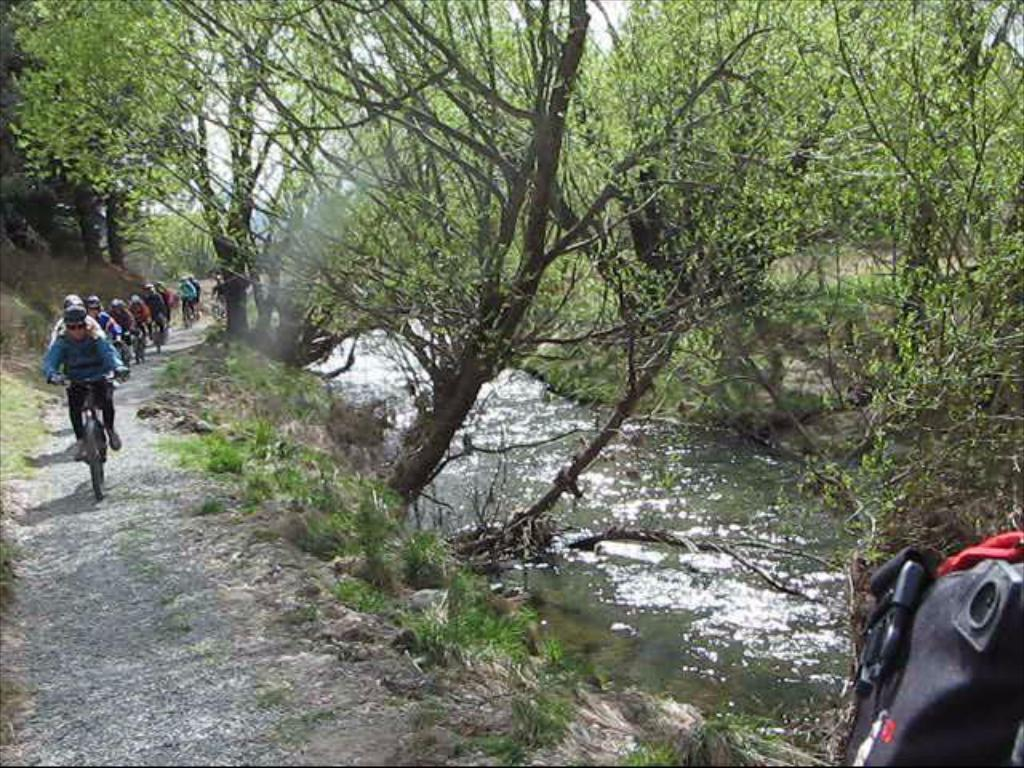What activity are the people on the left side of the image engaged in? There is a group of people riding cycles on the left side of the image. What can be seen in the middle of the image? Water is flowing in the middle of the image. What type of vegetation is present in the image? There are green trees in the image. What type of bread can be seen floating on the water in the image? There is no bread present in the image; it features a group of people riding cycles, water flowing, and green trees. What is the island's name in the image? There is no island present in the image. 